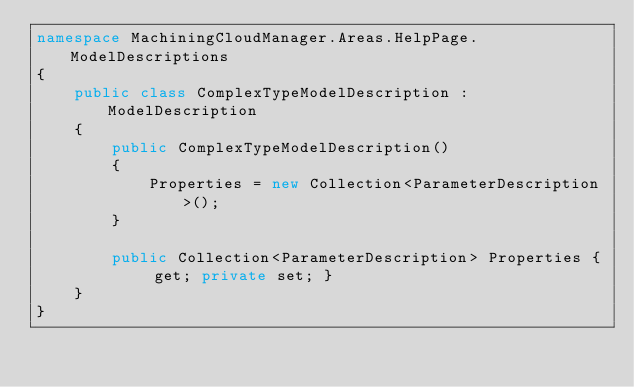Convert code to text. <code><loc_0><loc_0><loc_500><loc_500><_C#_>namespace MachiningCloudManager.Areas.HelpPage.ModelDescriptions
{
    public class ComplexTypeModelDescription : ModelDescription
    {
        public ComplexTypeModelDescription()
        {
            Properties = new Collection<ParameterDescription>();
        }

        public Collection<ParameterDescription> Properties { get; private set; }
    }
}</code> 